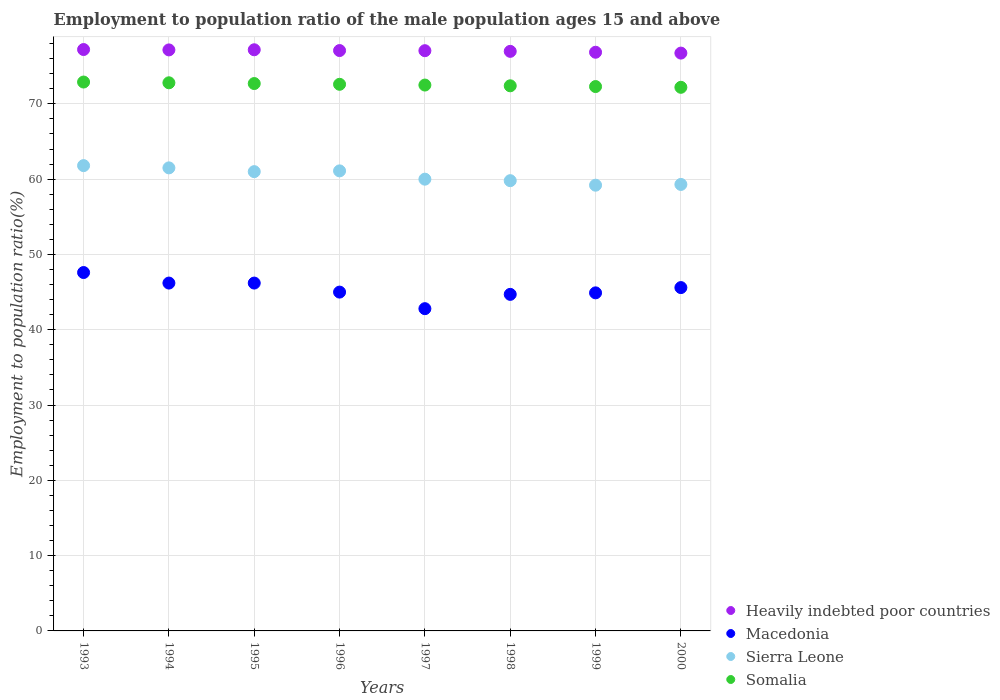What is the employment to population ratio in Macedonia in 1997?
Provide a short and direct response. 42.8. Across all years, what is the maximum employment to population ratio in Heavily indebted poor countries?
Provide a succinct answer. 77.22. Across all years, what is the minimum employment to population ratio in Somalia?
Make the answer very short. 72.2. In which year was the employment to population ratio in Somalia maximum?
Offer a very short reply. 1993. What is the total employment to population ratio in Macedonia in the graph?
Give a very brief answer. 363. What is the difference between the employment to population ratio in Sierra Leone in 1995 and that in 1996?
Your answer should be compact. -0.1. What is the difference between the employment to population ratio in Somalia in 1994 and the employment to population ratio in Heavily indebted poor countries in 1997?
Offer a very short reply. -4.26. What is the average employment to population ratio in Somalia per year?
Provide a short and direct response. 72.55. In the year 1993, what is the difference between the employment to population ratio in Macedonia and employment to population ratio in Heavily indebted poor countries?
Ensure brevity in your answer.  -29.62. What is the ratio of the employment to population ratio in Heavily indebted poor countries in 1996 to that in 1997?
Give a very brief answer. 1. Is the employment to population ratio in Macedonia in 1994 less than that in 1998?
Offer a very short reply. No. What is the difference between the highest and the second highest employment to population ratio in Sierra Leone?
Make the answer very short. 0.3. What is the difference between the highest and the lowest employment to population ratio in Macedonia?
Your answer should be compact. 4.8. Is the sum of the employment to population ratio in Sierra Leone in 1994 and 1995 greater than the maximum employment to population ratio in Heavily indebted poor countries across all years?
Keep it short and to the point. Yes. Is it the case that in every year, the sum of the employment to population ratio in Macedonia and employment to population ratio in Somalia  is greater than the employment to population ratio in Sierra Leone?
Offer a very short reply. Yes. How many dotlines are there?
Provide a short and direct response. 4. Where does the legend appear in the graph?
Give a very brief answer. Bottom right. What is the title of the graph?
Make the answer very short. Employment to population ratio of the male population ages 15 and above. Does "East Asia (all income levels)" appear as one of the legend labels in the graph?
Your answer should be very brief. No. What is the label or title of the Y-axis?
Offer a very short reply. Employment to population ratio(%). What is the Employment to population ratio(%) in Heavily indebted poor countries in 1993?
Your answer should be very brief. 77.22. What is the Employment to population ratio(%) of Macedonia in 1993?
Provide a short and direct response. 47.6. What is the Employment to population ratio(%) of Sierra Leone in 1993?
Offer a terse response. 61.8. What is the Employment to population ratio(%) of Somalia in 1993?
Provide a succinct answer. 72.9. What is the Employment to population ratio(%) in Heavily indebted poor countries in 1994?
Your answer should be compact. 77.17. What is the Employment to population ratio(%) in Macedonia in 1994?
Your answer should be very brief. 46.2. What is the Employment to population ratio(%) of Sierra Leone in 1994?
Your response must be concise. 61.5. What is the Employment to population ratio(%) in Somalia in 1994?
Your answer should be compact. 72.8. What is the Employment to population ratio(%) of Heavily indebted poor countries in 1995?
Give a very brief answer. 77.19. What is the Employment to population ratio(%) in Macedonia in 1995?
Your answer should be compact. 46.2. What is the Employment to population ratio(%) of Sierra Leone in 1995?
Provide a short and direct response. 61. What is the Employment to population ratio(%) of Somalia in 1995?
Provide a succinct answer. 72.7. What is the Employment to population ratio(%) of Heavily indebted poor countries in 1996?
Provide a short and direct response. 77.08. What is the Employment to population ratio(%) of Sierra Leone in 1996?
Your answer should be compact. 61.1. What is the Employment to population ratio(%) of Somalia in 1996?
Provide a short and direct response. 72.6. What is the Employment to population ratio(%) of Heavily indebted poor countries in 1997?
Offer a very short reply. 77.06. What is the Employment to population ratio(%) of Macedonia in 1997?
Make the answer very short. 42.8. What is the Employment to population ratio(%) in Sierra Leone in 1997?
Your answer should be very brief. 60. What is the Employment to population ratio(%) of Somalia in 1997?
Ensure brevity in your answer.  72.5. What is the Employment to population ratio(%) in Heavily indebted poor countries in 1998?
Offer a very short reply. 76.97. What is the Employment to population ratio(%) of Macedonia in 1998?
Keep it short and to the point. 44.7. What is the Employment to population ratio(%) in Sierra Leone in 1998?
Your answer should be compact. 59.8. What is the Employment to population ratio(%) of Somalia in 1998?
Your response must be concise. 72.4. What is the Employment to population ratio(%) in Heavily indebted poor countries in 1999?
Make the answer very short. 76.86. What is the Employment to population ratio(%) of Macedonia in 1999?
Provide a succinct answer. 44.9. What is the Employment to population ratio(%) of Sierra Leone in 1999?
Your answer should be very brief. 59.2. What is the Employment to population ratio(%) in Somalia in 1999?
Make the answer very short. 72.3. What is the Employment to population ratio(%) in Heavily indebted poor countries in 2000?
Give a very brief answer. 76.74. What is the Employment to population ratio(%) of Macedonia in 2000?
Offer a very short reply. 45.6. What is the Employment to population ratio(%) in Sierra Leone in 2000?
Make the answer very short. 59.3. What is the Employment to population ratio(%) of Somalia in 2000?
Offer a terse response. 72.2. Across all years, what is the maximum Employment to population ratio(%) in Heavily indebted poor countries?
Your response must be concise. 77.22. Across all years, what is the maximum Employment to population ratio(%) in Macedonia?
Offer a very short reply. 47.6. Across all years, what is the maximum Employment to population ratio(%) of Sierra Leone?
Provide a short and direct response. 61.8. Across all years, what is the maximum Employment to population ratio(%) of Somalia?
Offer a very short reply. 72.9. Across all years, what is the minimum Employment to population ratio(%) of Heavily indebted poor countries?
Offer a very short reply. 76.74. Across all years, what is the minimum Employment to population ratio(%) in Macedonia?
Your response must be concise. 42.8. Across all years, what is the minimum Employment to population ratio(%) of Sierra Leone?
Give a very brief answer. 59.2. Across all years, what is the minimum Employment to population ratio(%) of Somalia?
Your answer should be compact. 72.2. What is the total Employment to population ratio(%) in Heavily indebted poor countries in the graph?
Your answer should be very brief. 616.29. What is the total Employment to population ratio(%) in Macedonia in the graph?
Offer a terse response. 363. What is the total Employment to population ratio(%) in Sierra Leone in the graph?
Make the answer very short. 483.7. What is the total Employment to population ratio(%) of Somalia in the graph?
Make the answer very short. 580.4. What is the difference between the Employment to population ratio(%) in Heavily indebted poor countries in 1993 and that in 1994?
Give a very brief answer. 0.05. What is the difference between the Employment to population ratio(%) of Macedonia in 1993 and that in 1994?
Keep it short and to the point. 1.4. What is the difference between the Employment to population ratio(%) in Sierra Leone in 1993 and that in 1994?
Keep it short and to the point. 0.3. What is the difference between the Employment to population ratio(%) in Heavily indebted poor countries in 1993 and that in 1995?
Offer a very short reply. 0.03. What is the difference between the Employment to population ratio(%) in Macedonia in 1993 and that in 1995?
Provide a succinct answer. 1.4. What is the difference between the Employment to population ratio(%) of Sierra Leone in 1993 and that in 1995?
Offer a very short reply. 0.8. What is the difference between the Employment to population ratio(%) in Heavily indebted poor countries in 1993 and that in 1996?
Keep it short and to the point. 0.14. What is the difference between the Employment to population ratio(%) of Macedonia in 1993 and that in 1996?
Give a very brief answer. 2.6. What is the difference between the Employment to population ratio(%) in Sierra Leone in 1993 and that in 1996?
Ensure brevity in your answer.  0.7. What is the difference between the Employment to population ratio(%) of Somalia in 1993 and that in 1996?
Your response must be concise. 0.3. What is the difference between the Employment to population ratio(%) of Heavily indebted poor countries in 1993 and that in 1997?
Your answer should be compact. 0.15. What is the difference between the Employment to population ratio(%) in Sierra Leone in 1993 and that in 1997?
Provide a short and direct response. 1.8. What is the difference between the Employment to population ratio(%) of Somalia in 1993 and that in 1997?
Provide a succinct answer. 0.4. What is the difference between the Employment to population ratio(%) of Heavily indebted poor countries in 1993 and that in 1998?
Provide a short and direct response. 0.24. What is the difference between the Employment to population ratio(%) of Macedonia in 1993 and that in 1998?
Ensure brevity in your answer.  2.9. What is the difference between the Employment to population ratio(%) in Sierra Leone in 1993 and that in 1998?
Offer a terse response. 2. What is the difference between the Employment to population ratio(%) of Somalia in 1993 and that in 1998?
Offer a terse response. 0.5. What is the difference between the Employment to population ratio(%) in Heavily indebted poor countries in 1993 and that in 1999?
Your answer should be compact. 0.36. What is the difference between the Employment to population ratio(%) of Macedonia in 1993 and that in 1999?
Your answer should be compact. 2.7. What is the difference between the Employment to population ratio(%) in Somalia in 1993 and that in 1999?
Your answer should be compact. 0.6. What is the difference between the Employment to population ratio(%) of Heavily indebted poor countries in 1993 and that in 2000?
Ensure brevity in your answer.  0.47. What is the difference between the Employment to population ratio(%) of Macedonia in 1993 and that in 2000?
Keep it short and to the point. 2. What is the difference between the Employment to population ratio(%) of Sierra Leone in 1993 and that in 2000?
Make the answer very short. 2.5. What is the difference between the Employment to population ratio(%) in Somalia in 1993 and that in 2000?
Give a very brief answer. 0.7. What is the difference between the Employment to population ratio(%) of Heavily indebted poor countries in 1994 and that in 1995?
Make the answer very short. -0.02. What is the difference between the Employment to population ratio(%) of Sierra Leone in 1994 and that in 1995?
Keep it short and to the point. 0.5. What is the difference between the Employment to population ratio(%) in Somalia in 1994 and that in 1995?
Give a very brief answer. 0.1. What is the difference between the Employment to population ratio(%) in Heavily indebted poor countries in 1994 and that in 1996?
Your answer should be very brief. 0.09. What is the difference between the Employment to population ratio(%) of Macedonia in 1994 and that in 1996?
Offer a terse response. 1.2. What is the difference between the Employment to population ratio(%) of Heavily indebted poor countries in 1994 and that in 1997?
Your answer should be very brief. 0.1. What is the difference between the Employment to population ratio(%) of Macedonia in 1994 and that in 1997?
Ensure brevity in your answer.  3.4. What is the difference between the Employment to population ratio(%) in Sierra Leone in 1994 and that in 1997?
Your answer should be compact. 1.5. What is the difference between the Employment to population ratio(%) in Somalia in 1994 and that in 1997?
Offer a terse response. 0.3. What is the difference between the Employment to population ratio(%) in Heavily indebted poor countries in 1994 and that in 1998?
Keep it short and to the point. 0.19. What is the difference between the Employment to population ratio(%) in Macedonia in 1994 and that in 1998?
Your answer should be compact. 1.5. What is the difference between the Employment to population ratio(%) of Heavily indebted poor countries in 1994 and that in 1999?
Make the answer very short. 0.31. What is the difference between the Employment to population ratio(%) in Macedonia in 1994 and that in 1999?
Provide a short and direct response. 1.3. What is the difference between the Employment to population ratio(%) in Heavily indebted poor countries in 1994 and that in 2000?
Provide a short and direct response. 0.42. What is the difference between the Employment to population ratio(%) in Heavily indebted poor countries in 1995 and that in 1996?
Keep it short and to the point. 0.1. What is the difference between the Employment to population ratio(%) in Sierra Leone in 1995 and that in 1996?
Provide a short and direct response. -0.1. What is the difference between the Employment to population ratio(%) of Heavily indebted poor countries in 1995 and that in 1997?
Give a very brief answer. 0.12. What is the difference between the Employment to population ratio(%) of Sierra Leone in 1995 and that in 1997?
Offer a terse response. 1. What is the difference between the Employment to population ratio(%) of Heavily indebted poor countries in 1995 and that in 1998?
Give a very brief answer. 0.21. What is the difference between the Employment to population ratio(%) of Macedonia in 1995 and that in 1998?
Ensure brevity in your answer.  1.5. What is the difference between the Employment to population ratio(%) of Somalia in 1995 and that in 1998?
Ensure brevity in your answer.  0.3. What is the difference between the Employment to population ratio(%) in Heavily indebted poor countries in 1995 and that in 1999?
Keep it short and to the point. 0.33. What is the difference between the Employment to population ratio(%) of Sierra Leone in 1995 and that in 1999?
Your answer should be very brief. 1.8. What is the difference between the Employment to population ratio(%) of Somalia in 1995 and that in 1999?
Provide a short and direct response. 0.4. What is the difference between the Employment to population ratio(%) in Heavily indebted poor countries in 1995 and that in 2000?
Make the answer very short. 0.44. What is the difference between the Employment to population ratio(%) of Heavily indebted poor countries in 1996 and that in 1997?
Offer a terse response. 0.02. What is the difference between the Employment to population ratio(%) of Macedonia in 1996 and that in 1997?
Your answer should be compact. 2.2. What is the difference between the Employment to population ratio(%) in Sierra Leone in 1996 and that in 1997?
Ensure brevity in your answer.  1.1. What is the difference between the Employment to population ratio(%) of Somalia in 1996 and that in 1997?
Provide a succinct answer. 0.1. What is the difference between the Employment to population ratio(%) in Heavily indebted poor countries in 1996 and that in 1998?
Your response must be concise. 0.11. What is the difference between the Employment to population ratio(%) in Somalia in 1996 and that in 1998?
Offer a very short reply. 0.2. What is the difference between the Employment to population ratio(%) in Heavily indebted poor countries in 1996 and that in 1999?
Provide a succinct answer. 0.23. What is the difference between the Employment to population ratio(%) in Macedonia in 1996 and that in 1999?
Offer a very short reply. 0.1. What is the difference between the Employment to population ratio(%) in Somalia in 1996 and that in 1999?
Provide a short and direct response. 0.3. What is the difference between the Employment to population ratio(%) of Heavily indebted poor countries in 1996 and that in 2000?
Give a very brief answer. 0.34. What is the difference between the Employment to population ratio(%) of Macedonia in 1996 and that in 2000?
Keep it short and to the point. -0.6. What is the difference between the Employment to population ratio(%) in Heavily indebted poor countries in 1997 and that in 1998?
Your answer should be very brief. 0.09. What is the difference between the Employment to population ratio(%) in Heavily indebted poor countries in 1997 and that in 1999?
Provide a succinct answer. 0.21. What is the difference between the Employment to population ratio(%) of Macedonia in 1997 and that in 1999?
Your answer should be very brief. -2.1. What is the difference between the Employment to population ratio(%) of Sierra Leone in 1997 and that in 1999?
Ensure brevity in your answer.  0.8. What is the difference between the Employment to population ratio(%) of Heavily indebted poor countries in 1997 and that in 2000?
Your response must be concise. 0.32. What is the difference between the Employment to population ratio(%) of Macedonia in 1997 and that in 2000?
Your response must be concise. -2.8. What is the difference between the Employment to population ratio(%) in Sierra Leone in 1997 and that in 2000?
Your response must be concise. 0.7. What is the difference between the Employment to population ratio(%) in Heavily indebted poor countries in 1998 and that in 1999?
Make the answer very short. 0.12. What is the difference between the Employment to population ratio(%) in Sierra Leone in 1998 and that in 1999?
Provide a succinct answer. 0.6. What is the difference between the Employment to population ratio(%) of Heavily indebted poor countries in 1998 and that in 2000?
Provide a short and direct response. 0.23. What is the difference between the Employment to population ratio(%) in Macedonia in 1998 and that in 2000?
Keep it short and to the point. -0.9. What is the difference between the Employment to population ratio(%) in Sierra Leone in 1998 and that in 2000?
Offer a terse response. 0.5. What is the difference between the Employment to population ratio(%) of Heavily indebted poor countries in 1999 and that in 2000?
Your response must be concise. 0.11. What is the difference between the Employment to population ratio(%) of Heavily indebted poor countries in 1993 and the Employment to population ratio(%) of Macedonia in 1994?
Offer a very short reply. 31.02. What is the difference between the Employment to population ratio(%) in Heavily indebted poor countries in 1993 and the Employment to population ratio(%) in Sierra Leone in 1994?
Ensure brevity in your answer.  15.72. What is the difference between the Employment to population ratio(%) in Heavily indebted poor countries in 1993 and the Employment to population ratio(%) in Somalia in 1994?
Make the answer very short. 4.42. What is the difference between the Employment to population ratio(%) of Macedonia in 1993 and the Employment to population ratio(%) of Somalia in 1994?
Your answer should be compact. -25.2. What is the difference between the Employment to population ratio(%) in Sierra Leone in 1993 and the Employment to population ratio(%) in Somalia in 1994?
Offer a terse response. -11. What is the difference between the Employment to population ratio(%) of Heavily indebted poor countries in 1993 and the Employment to population ratio(%) of Macedonia in 1995?
Your answer should be compact. 31.02. What is the difference between the Employment to population ratio(%) of Heavily indebted poor countries in 1993 and the Employment to population ratio(%) of Sierra Leone in 1995?
Offer a very short reply. 16.22. What is the difference between the Employment to population ratio(%) in Heavily indebted poor countries in 1993 and the Employment to population ratio(%) in Somalia in 1995?
Offer a terse response. 4.52. What is the difference between the Employment to population ratio(%) of Macedonia in 1993 and the Employment to population ratio(%) of Somalia in 1995?
Give a very brief answer. -25.1. What is the difference between the Employment to population ratio(%) in Sierra Leone in 1993 and the Employment to population ratio(%) in Somalia in 1995?
Offer a terse response. -10.9. What is the difference between the Employment to population ratio(%) in Heavily indebted poor countries in 1993 and the Employment to population ratio(%) in Macedonia in 1996?
Offer a terse response. 32.22. What is the difference between the Employment to population ratio(%) of Heavily indebted poor countries in 1993 and the Employment to population ratio(%) of Sierra Leone in 1996?
Provide a short and direct response. 16.12. What is the difference between the Employment to population ratio(%) in Heavily indebted poor countries in 1993 and the Employment to population ratio(%) in Somalia in 1996?
Offer a terse response. 4.62. What is the difference between the Employment to population ratio(%) in Macedonia in 1993 and the Employment to population ratio(%) in Sierra Leone in 1996?
Offer a terse response. -13.5. What is the difference between the Employment to population ratio(%) of Macedonia in 1993 and the Employment to population ratio(%) of Somalia in 1996?
Your answer should be compact. -25. What is the difference between the Employment to population ratio(%) in Sierra Leone in 1993 and the Employment to population ratio(%) in Somalia in 1996?
Your answer should be very brief. -10.8. What is the difference between the Employment to population ratio(%) of Heavily indebted poor countries in 1993 and the Employment to population ratio(%) of Macedonia in 1997?
Give a very brief answer. 34.42. What is the difference between the Employment to population ratio(%) in Heavily indebted poor countries in 1993 and the Employment to population ratio(%) in Sierra Leone in 1997?
Your answer should be compact. 17.22. What is the difference between the Employment to population ratio(%) in Heavily indebted poor countries in 1993 and the Employment to population ratio(%) in Somalia in 1997?
Your response must be concise. 4.72. What is the difference between the Employment to population ratio(%) in Macedonia in 1993 and the Employment to population ratio(%) in Somalia in 1997?
Offer a terse response. -24.9. What is the difference between the Employment to population ratio(%) of Sierra Leone in 1993 and the Employment to population ratio(%) of Somalia in 1997?
Offer a very short reply. -10.7. What is the difference between the Employment to population ratio(%) in Heavily indebted poor countries in 1993 and the Employment to population ratio(%) in Macedonia in 1998?
Your response must be concise. 32.52. What is the difference between the Employment to population ratio(%) in Heavily indebted poor countries in 1993 and the Employment to population ratio(%) in Sierra Leone in 1998?
Your response must be concise. 17.42. What is the difference between the Employment to population ratio(%) of Heavily indebted poor countries in 1993 and the Employment to population ratio(%) of Somalia in 1998?
Give a very brief answer. 4.82. What is the difference between the Employment to population ratio(%) of Macedonia in 1993 and the Employment to population ratio(%) of Somalia in 1998?
Make the answer very short. -24.8. What is the difference between the Employment to population ratio(%) in Heavily indebted poor countries in 1993 and the Employment to population ratio(%) in Macedonia in 1999?
Your response must be concise. 32.32. What is the difference between the Employment to population ratio(%) of Heavily indebted poor countries in 1993 and the Employment to population ratio(%) of Sierra Leone in 1999?
Make the answer very short. 18.02. What is the difference between the Employment to population ratio(%) of Heavily indebted poor countries in 1993 and the Employment to population ratio(%) of Somalia in 1999?
Keep it short and to the point. 4.92. What is the difference between the Employment to population ratio(%) in Macedonia in 1993 and the Employment to population ratio(%) in Somalia in 1999?
Your response must be concise. -24.7. What is the difference between the Employment to population ratio(%) of Sierra Leone in 1993 and the Employment to population ratio(%) of Somalia in 1999?
Keep it short and to the point. -10.5. What is the difference between the Employment to population ratio(%) of Heavily indebted poor countries in 1993 and the Employment to population ratio(%) of Macedonia in 2000?
Ensure brevity in your answer.  31.62. What is the difference between the Employment to population ratio(%) of Heavily indebted poor countries in 1993 and the Employment to population ratio(%) of Sierra Leone in 2000?
Ensure brevity in your answer.  17.92. What is the difference between the Employment to population ratio(%) of Heavily indebted poor countries in 1993 and the Employment to population ratio(%) of Somalia in 2000?
Provide a short and direct response. 5.02. What is the difference between the Employment to population ratio(%) in Macedonia in 1993 and the Employment to population ratio(%) in Somalia in 2000?
Your answer should be compact. -24.6. What is the difference between the Employment to population ratio(%) in Heavily indebted poor countries in 1994 and the Employment to population ratio(%) in Macedonia in 1995?
Provide a short and direct response. 30.97. What is the difference between the Employment to population ratio(%) of Heavily indebted poor countries in 1994 and the Employment to population ratio(%) of Sierra Leone in 1995?
Your answer should be very brief. 16.17. What is the difference between the Employment to population ratio(%) in Heavily indebted poor countries in 1994 and the Employment to population ratio(%) in Somalia in 1995?
Keep it short and to the point. 4.47. What is the difference between the Employment to population ratio(%) of Macedonia in 1994 and the Employment to population ratio(%) of Sierra Leone in 1995?
Your response must be concise. -14.8. What is the difference between the Employment to population ratio(%) in Macedonia in 1994 and the Employment to population ratio(%) in Somalia in 1995?
Offer a terse response. -26.5. What is the difference between the Employment to population ratio(%) in Heavily indebted poor countries in 1994 and the Employment to population ratio(%) in Macedonia in 1996?
Provide a short and direct response. 32.17. What is the difference between the Employment to population ratio(%) in Heavily indebted poor countries in 1994 and the Employment to population ratio(%) in Sierra Leone in 1996?
Your answer should be compact. 16.07. What is the difference between the Employment to population ratio(%) of Heavily indebted poor countries in 1994 and the Employment to population ratio(%) of Somalia in 1996?
Provide a succinct answer. 4.57. What is the difference between the Employment to population ratio(%) of Macedonia in 1994 and the Employment to population ratio(%) of Sierra Leone in 1996?
Keep it short and to the point. -14.9. What is the difference between the Employment to population ratio(%) of Macedonia in 1994 and the Employment to population ratio(%) of Somalia in 1996?
Offer a terse response. -26.4. What is the difference between the Employment to population ratio(%) in Heavily indebted poor countries in 1994 and the Employment to population ratio(%) in Macedonia in 1997?
Provide a short and direct response. 34.37. What is the difference between the Employment to population ratio(%) of Heavily indebted poor countries in 1994 and the Employment to population ratio(%) of Sierra Leone in 1997?
Your response must be concise. 17.17. What is the difference between the Employment to population ratio(%) of Heavily indebted poor countries in 1994 and the Employment to population ratio(%) of Somalia in 1997?
Offer a terse response. 4.67. What is the difference between the Employment to population ratio(%) of Macedonia in 1994 and the Employment to population ratio(%) of Somalia in 1997?
Your answer should be very brief. -26.3. What is the difference between the Employment to population ratio(%) in Sierra Leone in 1994 and the Employment to population ratio(%) in Somalia in 1997?
Provide a short and direct response. -11. What is the difference between the Employment to population ratio(%) in Heavily indebted poor countries in 1994 and the Employment to population ratio(%) in Macedonia in 1998?
Your answer should be compact. 32.47. What is the difference between the Employment to population ratio(%) in Heavily indebted poor countries in 1994 and the Employment to population ratio(%) in Sierra Leone in 1998?
Provide a short and direct response. 17.37. What is the difference between the Employment to population ratio(%) in Heavily indebted poor countries in 1994 and the Employment to population ratio(%) in Somalia in 1998?
Keep it short and to the point. 4.77. What is the difference between the Employment to population ratio(%) of Macedonia in 1994 and the Employment to population ratio(%) of Sierra Leone in 1998?
Provide a succinct answer. -13.6. What is the difference between the Employment to population ratio(%) in Macedonia in 1994 and the Employment to population ratio(%) in Somalia in 1998?
Make the answer very short. -26.2. What is the difference between the Employment to population ratio(%) of Sierra Leone in 1994 and the Employment to population ratio(%) of Somalia in 1998?
Ensure brevity in your answer.  -10.9. What is the difference between the Employment to population ratio(%) in Heavily indebted poor countries in 1994 and the Employment to population ratio(%) in Macedonia in 1999?
Ensure brevity in your answer.  32.27. What is the difference between the Employment to population ratio(%) of Heavily indebted poor countries in 1994 and the Employment to population ratio(%) of Sierra Leone in 1999?
Ensure brevity in your answer.  17.97. What is the difference between the Employment to population ratio(%) of Heavily indebted poor countries in 1994 and the Employment to population ratio(%) of Somalia in 1999?
Ensure brevity in your answer.  4.87. What is the difference between the Employment to population ratio(%) of Macedonia in 1994 and the Employment to population ratio(%) of Sierra Leone in 1999?
Provide a succinct answer. -13. What is the difference between the Employment to population ratio(%) of Macedonia in 1994 and the Employment to population ratio(%) of Somalia in 1999?
Make the answer very short. -26.1. What is the difference between the Employment to population ratio(%) in Sierra Leone in 1994 and the Employment to population ratio(%) in Somalia in 1999?
Keep it short and to the point. -10.8. What is the difference between the Employment to population ratio(%) of Heavily indebted poor countries in 1994 and the Employment to population ratio(%) of Macedonia in 2000?
Offer a very short reply. 31.57. What is the difference between the Employment to population ratio(%) in Heavily indebted poor countries in 1994 and the Employment to population ratio(%) in Sierra Leone in 2000?
Make the answer very short. 17.87. What is the difference between the Employment to population ratio(%) in Heavily indebted poor countries in 1994 and the Employment to population ratio(%) in Somalia in 2000?
Offer a very short reply. 4.97. What is the difference between the Employment to population ratio(%) in Macedonia in 1994 and the Employment to population ratio(%) in Sierra Leone in 2000?
Keep it short and to the point. -13.1. What is the difference between the Employment to population ratio(%) of Sierra Leone in 1994 and the Employment to population ratio(%) of Somalia in 2000?
Provide a succinct answer. -10.7. What is the difference between the Employment to population ratio(%) in Heavily indebted poor countries in 1995 and the Employment to population ratio(%) in Macedonia in 1996?
Your response must be concise. 32.19. What is the difference between the Employment to population ratio(%) of Heavily indebted poor countries in 1995 and the Employment to population ratio(%) of Sierra Leone in 1996?
Offer a very short reply. 16.09. What is the difference between the Employment to population ratio(%) of Heavily indebted poor countries in 1995 and the Employment to population ratio(%) of Somalia in 1996?
Offer a very short reply. 4.59. What is the difference between the Employment to population ratio(%) in Macedonia in 1995 and the Employment to population ratio(%) in Sierra Leone in 1996?
Your answer should be compact. -14.9. What is the difference between the Employment to population ratio(%) of Macedonia in 1995 and the Employment to population ratio(%) of Somalia in 1996?
Give a very brief answer. -26.4. What is the difference between the Employment to population ratio(%) in Heavily indebted poor countries in 1995 and the Employment to population ratio(%) in Macedonia in 1997?
Provide a succinct answer. 34.39. What is the difference between the Employment to population ratio(%) in Heavily indebted poor countries in 1995 and the Employment to population ratio(%) in Sierra Leone in 1997?
Provide a short and direct response. 17.19. What is the difference between the Employment to population ratio(%) in Heavily indebted poor countries in 1995 and the Employment to population ratio(%) in Somalia in 1997?
Offer a very short reply. 4.69. What is the difference between the Employment to population ratio(%) in Macedonia in 1995 and the Employment to population ratio(%) in Sierra Leone in 1997?
Your response must be concise. -13.8. What is the difference between the Employment to population ratio(%) in Macedonia in 1995 and the Employment to population ratio(%) in Somalia in 1997?
Keep it short and to the point. -26.3. What is the difference between the Employment to population ratio(%) of Sierra Leone in 1995 and the Employment to population ratio(%) of Somalia in 1997?
Your answer should be compact. -11.5. What is the difference between the Employment to population ratio(%) in Heavily indebted poor countries in 1995 and the Employment to population ratio(%) in Macedonia in 1998?
Offer a very short reply. 32.49. What is the difference between the Employment to population ratio(%) of Heavily indebted poor countries in 1995 and the Employment to population ratio(%) of Sierra Leone in 1998?
Provide a succinct answer. 17.39. What is the difference between the Employment to population ratio(%) of Heavily indebted poor countries in 1995 and the Employment to population ratio(%) of Somalia in 1998?
Your response must be concise. 4.79. What is the difference between the Employment to population ratio(%) of Macedonia in 1995 and the Employment to population ratio(%) of Somalia in 1998?
Offer a terse response. -26.2. What is the difference between the Employment to population ratio(%) in Heavily indebted poor countries in 1995 and the Employment to population ratio(%) in Macedonia in 1999?
Provide a succinct answer. 32.29. What is the difference between the Employment to population ratio(%) of Heavily indebted poor countries in 1995 and the Employment to population ratio(%) of Sierra Leone in 1999?
Provide a short and direct response. 17.99. What is the difference between the Employment to population ratio(%) in Heavily indebted poor countries in 1995 and the Employment to population ratio(%) in Somalia in 1999?
Give a very brief answer. 4.89. What is the difference between the Employment to population ratio(%) in Macedonia in 1995 and the Employment to population ratio(%) in Somalia in 1999?
Your response must be concise. -26.1. What is the difference between the Employment to population ratio(%) of Heavily indebted poor countries in 1995 and the Employment to population ratio(%) of Macedonia in 2000?
Your answer should be compact. 31.59. What is the difference between the Employment to population ratio(%) of Heavily indebted poor countries in 1995 and the Employment to population ratio(%) of Sierra Leone in 2000?
Keep it short and to the point. 17.89. What is the difference between the Employment to population ratio(%) of Heavily indebted poor countries in 1995 and the Employment to population ratio(%) of Somalia in 2000?
Your answer should be compact. 4.99. What is the difference between the Employment to population ratio(%) of Macedonia in 1995 and the Employment to population ratio(%) of Somalia in 2000?
Your answer should be compact. -26. What is the difference between the Employment to population ratio(%) of Sierra Leone in 1995 and the Employment to population ratio(%) of Somalia in 2000?
Offer a very short reply. -11.2. What is the difference between the Employment to population ratio(%) in Heavily indebted poor countries in 1996 and the Employment to population ratio(%) in Macedonia in 1997?
Offer a very short reply. 34.28. What is the difference between the Employment to population ratio(%) in Heavily indebted poor countries in 1996 and the Employment to population ratio(%) in Sierra Leone in 1997?
Provide a short and direct response. 17.08. What is the difference between the Employment to population ratio(%) of Heavily indebted poor countries in 1996 and the Employment to population ratio(%) of Somalia in 1997?
Keep it short and to the point. 4.58. What is the difference between the Employment to population ratio(%) of Macedonia in 1996 and the Employment to population ratio(%) of Sierra Leone in 1997?
Provide a succinct answer. -15. What is the difference between the Employment to population ratio(%) in Macedonia in 1996 and the Employment to population ratio(%) in Somalia in 1997?
Ensure brevity in your answer.  -27.5. What is the difference between the Employment to population ratio(%) in Sierra Leone in 1996 and the Employment to population ratio(%) in Somalia in 1997?
Your response must be concise. -11.4. What is the difference between the Employment to population ratio(%) in Heavily indebted poor countries in 1996 and the Employment to population ratio(%) in Macedonia in 1998?
Offer a terse response. 32.38. What is the difference between the Employment to population ratio(%) of Heavily indebted poor countries in 1996 and the Employment to population ratio(%) of Sierra Leone in 1998?
Provide a short and direct response. 17.28. What is the difference between the Employment to population ratio(%) of Heavily indebted poor countries in 1996 and the Employment to population ratio(%) of Somalia in 1998?
Make the answer very short. 4.68. What is the difference between the Employment to population ratio(%) in Macedonia in 1996 and the Employment to population ratio(%) in Sierra Leone in 1998?
Provide a short and direct response. -14.8. What is the difference between the Employment to population ratio(%) in Macedonia in 1996 and the Employment to population ratio(%) in Somalia in 1998?
Provide a succinct answer. -27.4. What is the difference between the Employment to population ratio(%) of Sierra Leone in 1996 and the Employment to population ratio(%) of Somalia in 1998?
Make the answer very short. -11.3. What is the difference between the Employment to population ratio(%) in Heavily indebted poor countries in 1996 and the Employment to population ratio(%) in Macedonia in 1999?
Offer a very short reply. 32.18. What is the difference between the Employment to population ratio(%) of Heavily indebted poor countries in 1996 and the Employment to population ratio(%) of Sierra Leone in 1999?
Your answer should be compact. 17.88. What is the difference between the Employment to population ratio(%) of Heavily indebted poor countries in 1996 and the Employment to population ratio(%) of Somalia in 1999?
Offer a very short reply. 4.78. What is the difference between the Employment to population ratio(%) of Macedonia in 1996 and the Employment to population ratio(%) of Sierra Leone in 1999?
Make the answer very short. -14.2. What is the difference between the Employment to population ratio(%) in Macedonia in 1996 and the Employment to population ratio(%) in Somalia in 1999?
Make the answer very short. -27.3. What is the difference between the Employment to population ratio(%) of Sierra Leone in 1996 and the Employment to population ratio(%) of Somalia in 1999?
Your answer should be very brief. -11.2. What is the difference between the Employment to population ratio(%) of Heavily indebted poor countries in 1996 and the Employment to population ratio(%) of Macedonia in 2000?
Make the answer very short. 31.48. What is the difference between the Employment to population ratio(%) in Heavily indebted poor countries in 1996 and the Employment to population ratio(%) in Sierra Leone in 2000?
Offer a terse response. 17.78. What is the difference between the Employment to population ratio(%) in Heavily indebted poor countries in 1996 and the Employment to population ratio(%) in Somalia in 2000?
Give a very brief answer. 4.88. What is the difference between the Employment to population ratio(%) in Macedonia in 1996 and the Employment to population ratio(%) in Sierra Leone in 2000?
Provide a short and direct response. -14.3. What is the difference between the Employment to population ratio(%) in Macedonia in 1996 and the Employment to population ratio(%) in Somalia in 2000?
Ensure brevity in your answer.  -27.2. What is the difference between the Employment to population ratio(%) in Heavily indebted poor countries in 1997 and the Employment to population ratio(%) in Macedonia in 1998?
Provide a succinct answer. 32.36. What is the difference between the Employment to population ratio(%) in Heavily indebted poor countries in 1997 and the Employment to population ratio(%) in Sierra Leone in 1998?
Offer a terse response. 17.26. What is the difference between the Employment to population ratio(%) in Heavily indebted poor countries in 1997 and the Employment to population ratio(%) in Somalia in 1998?
Give a very brief answer. 4.66. What is the difference between the Employment to population ratio(%) of Macedonia in 1997 and the Employment to population ratio(%) of Sierra Leone in 1998?
Keep it short and to the point. -17. What is the difference between the Employment to population ratio(%) in Macedonia in 1997 and the Employment to population ratio(%) in Somalia in 1998?
Your answer should be compact. -29.6. What is the difference between the Employment to population ratio(%) in Sierra Leone in 1997 and the Employment to population ratio(%) in Somalia in 1998?
Ensure brevity in your answer.  -12.4. What is the difference between the Employment to population ratio(%) in Heavily indebted poor countries in 1997 and the Employment to population ratio(%) in Macedonia in 1999?
Provide a succinct answer. 32.16. What is the difference between the Employment to population ratio(%) of Heavily indebted poor countries in 1997 and the Employment to population ratio(%) of Sierra Leone in 1999?
Offer a very short reply. 17.86. What is the difference between the Employment to population ratio(%) of Heavily indebted poor countries in 1997 and the Employment to population ratio(%) of Somalia in 1999?
Provide a succinct answer. 4.76. What is the difference between the Employment to population ratio(%) of Macedonia in 1997 and the Employment to population ratio(%) of Sierra Leone in 1999?
Make the answer very short. -16.4. What is the difference between the Employment to population ratio(%) in Macedonia in 1997 and the Employment to population ratio(%) in Somalia in 1999?
Provide a succinct answer. -29.5. What is the difference between the Employment to population ratio(%) in Sierra Leone in 1997 and the Employment to population ratio(%) in Somalia in 1999?
Offer a very short reply. -12.3. What is the difference between the Employment to population ratio(%) of Heavily indebted poor countries in 1997 and the Employment to population ratio(%) of Macedonia in 2000?
Ensure brevity in your answer.  31.46. What is the difference between the Employment to population ratio(%) of Heavily indebted poor countries in 1997 and the Employment to population ratio(%) of Sierra Leone in 2000?
Make the answer very short. 17.76. What is the difference between the Employment to population ratio(%) of Heavily indebted poor countries in 1997 and the Employment to population ratio(%) of Somalia in 2000?
Offer a very short reply. 4.86. What is the difference between the Employment to population ratio(%) of Macedonia in 1997 and the Employment to population ratio(%) of Sierra Leone in 2000?
Ensure brevity in your answer.  -16.5. What is the difference between the Employment to population ratio(%) of Macedonia in 1997 and the Employment to population ratio(%) of Somalia in 2000?
Ensure brevity in your answer.  -29.4. What is the difference between the Employment to population ratio(%) in Sierra Leone in 1997 and the Employment to population ratio(%) in Somalia in 2000?
Your response must be concise. -12.2. What is the difference between the Employment to population ratio(%) of Heavily indebted poor countries in 1998 and the Employment to population ratio(%) of Macedonia in 1999?
Give a very brief answer. 32.07. What is the difference between the Employment to population ratio(%) in Heavily indebted poor countries in 1998 and the Employment to population ratio(%) in Sierra Leone in 1999?
Offer a very short reply. 17.77. What is the difference between the Employment to population ratio(%) of Heavily indebted poor countries in 1998 and the Employment to population ratio(%) of Somalia in 1999?
Ensure brevity in your answer.  4.67. What is the difference between the Employment to population ratio(%) of Macedonia in 1998 and the Employment to population ratio(%) of Somalia in 1999?
Offer a terse response. -27.6. What is the difference between the Employment to population ratio(%) of Sierra Leone in 1998 and the Employment to population ratio(%) of Somalia in 1999?
Your response must be concise. -12.5. What is the difference between the Employment to population ratio(%) of Heavily indebted poor countries in 1998 and the Employment to population ratio(%) of Macedonia in 2000?
Provide a succinct answer. 31.37. What is the difference between the Employment to population ratio(%) in Heavily indebted poor countries in 1998 and the Employment to population ratio(%) in Sierra Leone in 2000?
Provide a short and direct response. 17.67. What is the difference between the Employment to population ratio(%) of Heavily indebted poor countries in 1998 and the Employment to population ratio(%) of Somalia in 2000?
Your answer should be very brief. 4.77. What is the difference between the Employment to population ratio(%) in Macedonia in 1998 and the Employment to population ratio(%) in Sierra Leone in 2000?
Keep it short and to the point. -14.6. What is the difference between the Employment to population ratio(%) in Macedonia in 1998 and the Employment to population ratio(%) in Somalia in 2000?
Provide a short and direct response. -27.5. What is the difference between the Employment to population ratio(%) of Heavily indebted poor countries in 1999 and the Employment to population ratio(%) of Macedonia in 2000?
Provide a short and direct response. 31.26. What is the difference between the Employment to population ratio(%) of Heavily indebted poor countries in 1999 and the Employment to population ratio(%) of Sierra Leone in 2000?
Your answer should be compact. 17.56. What is the difference between the Employment to population ratio(%) in Heavily indebted poor countries in 1999 and the Employment to population ratio(%) in Somalia in 2000?
Your answer should be compact. 4.66. What is the difference between the Employment to population ratio(%) of Macedonia in 1999 and the Employment to population ratio(%) of Sierra Leone in 2000?
Give a very brief answer. -14.4. What is the difference between the Employment to population ratio(%) in Macedonia in 1999 and the Employment to population ratio(%) in Somalia in 2000?
Offer a very short reply. -27.3. What is the difference between the Employment to population ratio(%) in Sierra Leone in 1999 and the Employment to population ratio(%) in Somalia in 2000?
Ensure brevity in your answer.  -13. What is the average Employment to population ratio(%) in Heavily indebted poor countries per year?
Make the answer very short. 77.04. What is the average Employment to population ratio(%) in Macedonia per year?
Provide a short and direct response. 45.38. What is the average Employment to population ratio(%) of Sierra Leone per year?
Your response must be concise. 60.46. What is the average Employment to population ratio(%) in Somalia per year?
Ensure brevity in your answer.  72.55. In the year 1993, what is the difference between the Employment to population ratio(%) in Heavily indebted poor countries and Employment to population ratio(%) in Macedonia?
Make the answer very short. 29.62. In the year 1993, what is the difference between the Employment to population ratio(%) in Heavily indebted poor countries and Employment to population ratio(%) in Sierra Leone?
Your answer should be very brief. 15.42. In the year 1993, what is the difference between the Employment to population ratio(%) in Heavily indebted poor countries and Employment to population ratio(%) in Somalia?
Provide a succinct answer. 4.32. In the year 1993, what is the difference between the Employment to population ratio(%) in Macedonia and Employment to population ratio(%) in Sierra Leone?
Your response must be concise. -14.2. In the year 1993, what is the difference between the Employment to population ratio(%) in Macedonia and Employment to population ratio(%) in Somalia?
Your response must be concise. -25.3. In the year 1993, what is the difference between the Employment to population ratio(%) in Sierra Leone and Employment to population ratio(%) in Somalia?
Provide a succinct answer. -11.1. In the year 1994, what is the difference between the Employment to population ratio(%) of Heavily indebted poor countries and Employment to population ratio(%) of Macedonia?
Ensure brevity in your answer.  30.97. In the year 1994, what is the difference between the Employment to population ratio(%) of Heavily indebted poor countries and Employment to population ratio(%) of Sierra Leone?
Your response must be concise. 15.67. In the year 1994, what is the difference between the Employment to population ratio(%) of Heavily indebted poor countries and Employment to population ratio(%) of Somalia?
Keep it short and to the point. 4.37. In the year 1994, what is the difference between the Employment to population ratio(%) in Macedonia and Employment to population ratio(%) in Sierra Leone?
Offer a very short reply. -15.3. In the year 1994, what is the difference between the Employment to population ratio(%) in Macedonia and Employment to population ratio(%) in Somalia?
Your answer should be compact. -26.6. In the year 1994, what is the difference between the Employment to population ratio(%) of Sierra Leone and Employment to population ratio(%) of Somalia?
Make the answer very short. -11.3. In the year 1995, what is the difference between the Employment to population ratio(%) of Heavily indebted poor countries and Employment to population ratio(%) of Macedonia?
Ensure brevity in your answer.  30.99. In the year 1995, what is the difference between the Employment to population ratio(%) of Heavily indebted poor countries and Employment to population ratio(%) of Sierra Leone?
Make the answer very short. 16.19. In the year 1995, what is the difference between the Employment to population ratio(%) in Heavily indebted poor countries and Employment to population ratio(%) in Somalia?
Make the answer very short. 4.49. In the year 1995, what is the difference between the Employment to population ratio(%) in Macedonia and Employment to population ratio(%) in Sierra Leone?
Ensure brevity in your answer.  -14.8. In the year 1995, what is the difference between the Employment to population ratio(%) in Macedonia and Employment to population ratio(%) in Somalia?
Ensure brevity in your answer.  -26.5. In the year 1996, what is the difference between the Employment to population ratio(%) of Heavily indebted poor countries and Employment to population ratio(%) of Macedonia?
Ensure brevity in your answer.  32.08. In the year 1996, what is the difference between the Employment to population ratio(%) of Heavily indebted poor countries and Employment to population ratio(%) of Sierra Leone?
Make the answer very short. 15.98. In the year 1996, what is the difference between the Employment to population ratio(%) of Heavily indebted poor countries and Employment to population ratio(%) of Somalia?
Your answer should be compact. 4.48. In the year 1996, what is the difference between the Employment to population ratio(%) in Macedonia and Employment to population ratio(%) in Sierra Leone?
Provide a succinct answer. -16.1. In the year 1996, what is the difference between the Employment to population ratio(%) in Macedonia and Employment to population ratio(%) in Somalia?
Provide a short and direct response. -27.6. In the year 1997, what is the difference between the Employment to population ratio(%) of Heavily indebted poor countries and Employment to population ratio(%) of Macedonia?
Offer a terse response. 34.26. In the year 1997, what is the difference between the Employment to population ratio(%) of Heavily indebted poor countries and Employment to population ratio(%) of Sierra Leone?
Offer a very short reply. 17.06. In the year 1997, what is the difference between the Employment to population ratio(%) of Heavily indebted poor countries and Employment to population ratio(%) of Somalia?
Offer a very short reply. 4.56. In the year 1997, what is the difference between the Employment to population ratio(%) of Macedonia and Employment to population ratio(%) of Sierra Leone?
Your answer should be compact. -17.2. In the year 1997, what is the difference between the Employment to population ratio(%) in Macedonia and Employment to population ratio(%) in Somalia?
Your response must be concise. -29.7. In the year 1998, what is the difference between the Employment to population ratio(%) in Heavily indebted poor countries and Employment to population ratio(%) in Macedonia?
Your response must be concise. 32.27. In the year 1998, what is the difference between the Employment to population ratio(%) of Heavily indebted poor countries and Employment to population ratio(%) of Sierra Leone?
Ensure brevity in your answer.  17.17. In the year 1998, what is the difference between the Employment to population ratio(%) of Heavily indebted poor countries and Employment to population ratio(%) of Somalia?
Provide a short and direct response. 4.57. In the year 1998, what is the difference between the Employment to population ratio(%) in Macedonia and Employment to population ratio(%) in Sierra Leone?
Make the answer very short. -15.1. In the year 1998, what is the difference between the Employment to population ratio(%) in Macedonia and Employment to population ratio(%) in Somalia?
Keep it short and to the point. -27.7. In the year 1998, what is the difference between the Employment to population ratio(%) in Sierra Leone and Employment to population ratio(%) in Somalia?
Provide a succinct answer. -12.6. In the year 1999, what is the difference between the Employment to population ratio(%) of Heavily indebted poor countries and Employment to population ratio(%) of Macedonia?
Give a very brief answer. 31.96. In the year 1999, what is the difference between the Employment to population ratio(%) in Heavily indebted poor countries and Employment to population ratio(%) in Sierra Leone?
Offer a very short reply. 17.66. In the year 1999, what is the difference between the Employment to population ratio(%) of Heavily indebted poor countries and Employment to population ratio(%) of Somalia?
Your answer should be very brief. 4.56. In the year 1999, what is the difference between the Employment to population ratio(%) in Macedonia and Employment to population ratio(%) in Sierra Leone?
Make the answer very short. -14.3. In the year 1999, what is the difference between the Employment to population ratio(%) of Macedonia and Employment to population ratio(%) of Somalia?
Provide a short and direct response. -27.4. In the year 2000, what is the difference between the Employment to population ratio(%) of Heavily indebted poor countries and Employment to population ratio(%) of Macedonia?
Make the answer very short. 31.14. In the year 2000, what is the difference between the Employment to population ratio(%) in Heavily indebted poor countries and Employment to population ratio(%) in Sierra Leone?
Give a very brief answer. 17.44. In the year 2000, what is the difference between the Employment to population ratio(%) of Heavily indebted poor countries and Employment to population ratio(%) of Somalia?
Offer a terse response. 4.54. In the year 2000, what is the difference between the Employment to population ratio(%) in Macedonia and Employment to population ratio(%) in Sierra Leone?
Offer a terse response. -13.7. In the year 2000, what is the difference between the Employment to population ratio(%) in Macedonia and Employment to population ratio(%) in Somalia?
Your answer should be compact. -26.6. In the year 2000, what is the difference between the Employment to population ratio(%) in Sierra Leone and Employment to population ratio(%) in Somalia?
Give a very brief answer. -12.9. What is the ratio of the Employment to population ratio(%) of Heavily indebted poor countries in 1993 to that in 1994?
Keep it short and to the point. 1. What is the ratio of the Employment to population ratio(%) of Macedonia in 1993 to that in 1994?
Offer a very short reply. 1.03. What is the ratio of the Employment to population ratio(%) in Sierra Leone in 1993 to that in 1994?
Your answer should be very brief. 1. What is the ratio of the Employment to population ratio(%) of Macedonia in 1993 to that in 1995?
Your answer should be compact. 1.03. What is the ratio of the Employment to population ratio(%) in Sierra Leone in 1993 to that in 1995?
Make the answer very short. 1.01. What is the ratio of the Employment to population ratio(%) of Macedonia in 1993 to that in 1996?
Your response must be concise. 1.06. What is the ratio of the Employment to population ratio(%) in Sierra Leone in 1993 to that in 1996?
Your answer should be compact. 1.01. What is the ratio of the Employment to population ratio(%) in Macedonia in 1993 to that in 1997?
Keep it short and to the point. 1.11. What is the ratio of the Employment to population ratio(%) in Macedonia in 1993 to that in 1998?
Offer a very short reply. 1.06. What is the ratio of the Employment to population ratio(%) of Sierra Leone in 1993 to that in 1998?
Provide a succinct answer. 1.03. What is the ratio of the Employment to population ratio(%) of Somalia in 1993 to that in 1998?
Provide a succinct answer. 1.01. What is the ratio of the Employment to population ratio(%) in Heavily indebted poor countries in 1993 to that in 1999?
Make the answer very short. 1. What is the ratio of the Employment to population ratio(%) of Macedonia in 1993 to that in 1999?
Offer a terse response. 1.06. What is the ratio of the Employment to population ratio(%) of Sierra Leone in 1993 to that in 1999?
Ensure brevity in your answer.  1.04. What is the ratio of the Employment to population ratio(%) in Somalia in 1993 to that in 1999?
Offer a very short reply. 1.01. What is the ratio of the Employment to population ratio(%) in Macedonia in 1993 to that in 2000?
Give a very brief answer. 1.04. What is the ratio of the Employment to population ratio(%) in Sierra Leone in 1993 to that in 2000?
Keep it short and to the point. 1.04. What is the ratio of the Employment to population ratio(%) of Somalia in 1993 to that in 2000?
Your answer should be very brief. 1.01. What is the ratio of the Employment to population ratio(%) of Macedonia in 1994 to that in 1995?
Give a very brief answer. 1. What is the ratio of the Employment to population ratio(%) in Sierra Leone in 1994 to that in 1995?
Your response must be concise. 1.01. What is the ratio of the Employment to population ratio(%) of Somalia in 1994 to that in 1995?
Offer a terse response. 1. What is the ratio of the Employment to population ratio(%) of Heavily indebted poor countries in 1994 to that in 1996?
Your response must be concise. 1. What is the ratio of the Employment to population ratio(%) of Macedonia in 1994 to that in 1996?
Your answer should be compact. 1.03. What is the ratio of the Employment to population ratio(%) of Sierra Leone in 1994 to that in 1996?
Provide a succinct answer. 1.01. What is the ratio of the Employment to population ratio(%) of Somalia in 1994 to that in 1996?
Offer a very short reply. 1. What is the ratio of the Employment to population ratio(%) of Heavily indebted poor countries in 1994 to that in 1997?
Give a very brief answer. 1. What is the ratio of the Employment to population ratio(%) of Macedonia in 1994 to that in 1997?
Give a very brief answer. 1.08. What is the ratio of the Employment to population ratio(%) of Sierra Leone in 1994 to that in 1997?
Ensure brevity in your answer.  1.02. What is the ratio of the Employment to population ratio(%) in Macedonia in 1994 to that in 1998?
Ensure brevity in your answer.  1.03. What is the ratio of the Employment to population ratio(%) of Sierra Leone in 1994 to that in 1998?
Keep it short and to the point. 1.03. What is the ratio of the Employment to population ratio(%) in Heavily indebted poor countries in 1994 to that in 1999?
Offer a terse response. 1. What is the ratio of the Employment to population ratio(%) of Macedonia in 1994 to that in 1999?
Ensure brevity in your answer.  1.03. What is the ratio of the Employment to population ratio(%) of Sierra Leone in 1994 to that in 1999?
Ensure brevity in your answer.  1.04. What is the ratio of the Employment to population ratio(%) in Macedonia in 1994 to that in 2000?
Keep it short and to the point. 1.01. What is the ratio of the Employment to population ratio(%) in Sierra Leone in 1994 to that in 2000?
Keep it short and to the point. 1.04. What is the ratio of the Employment to population ratio(%) of Somalia in 1994 to that in 2000?
Ensure brevity in your answer.  1.01. What is the ratio of the Employment to population ratio(%) of Heavily indebted poor countries in 1995 to that in 1996?
Offer a terse response. 1. What is the ratio of the Employment to population ratio(%) of Macedonia in 1995 to that in 1996?
Your answer should be compact. 1.03. What is the ratio of the Employment to population ratio(%) in Sierra Leone in 1995 to that in 1996?
Ensure brevity in your answer.  1. What is the ratio of the Employment to population ratio(%) in Somalia in 1995 to that in 1996?
Make the answer very short. 1. What is the ratio of the Employment to population ratio(%) of Heavily indebted poor countries in 1995 to that in 1997?
Your answer should be compact. 1. What is the ratio of the Employment to population ratio(%) in Macedonia in 1995 to that in 1997?
Ensure brevity in your answer.  1.08. What is the ratio of the Employment to population ratio(%) in Sierra Leone in 1995 to that in 1997?
Provide a succinct answer. 1.02. What is the ratio of the Employment to population ratio(%) in Macedonia in 1995 to that in 1998?
Provide a short and direct response. 1.03. What is the ratio of the Employment to population ratio(%) of Sierra Leone in 1995 to that in 1998?
Ensure brevity in your answer.  1.02. What is the ratio of the Employment to population ratio(%) in Somalia in 1995 to that in 1998?
Provide a succinct answer. 1. What is the ratio of the Employment to population ratio(%) of Heavily indebted poor countries in 1995 to that in 1999?
Make the answer very short. 1. What is the ratio of the Employment to population ratio(%) of Macedonia in 1995 to that in 1999?
Provide a succinct answer. 1.03. What is the ratio of the Employment to population ratio(%) of Sierra Leone in 1995 to that in 1999?
Ensure brevity in your answer.  1.03. What is the ratio of the Employment to population ratio(%) in Macedonia in 1995 to that in 2000?
Ensure brevity in your answer.  1.01. What is the ratio of the Employment to population ratio(%) in Sierra Leone in 1995 to that in 2000?
Provide a succinct answer. 1.03. What is the ratio of the Employment to population ratio(%) in Somalia in 1995 to that in 2000?
Your response must be concise. 1.01. What is the ratio of the Employment to population ratio(%) of Macedonia in 1996 to that in 1997?
Give a very brief answer. 1.05. What is the ratio of the Employment to population ratio(%) in Sierra Leone in 1996 to that in 1997?
Give a very brief answer. 1.02. What is the ratio of the Employment to population ratio(%) of Sierra Leone in 1996 to that in 1998?
Your answer should be compact. 1.02. What is the ratio of the Employment to population ratio(%) in Macedonia in 1996 to that in 1999?
Keep it short and to the point. 1. What is the ratio of the Employment to population ratio(%) of Sierra Leone in 1996 to that in 1999?
Ensure brevity in your answer.  1.03. What is the ratio of the Employment to population ratio(%) in Sierra Leone in 1996 to that in 2000?
Provide a succinct answer. 1.03. What is the ratio of the Employment to population ratio(%) in Macedonia in 1997 to that in 1998?
Provide a succinct answer. 0.96. What is the ratio of the Employment to population ratio(%) in Somalia in 1997 to that in 1998?
Keep it short and to the point. 1. What is the ratio of the Employment to population ratio(%) of Macedonia in 1997 to that in 1999?
Your response must be concise. 0.95. What is the ratio of the Employment to population ratio(%) of Sierra Leone in 1997 to that in 1999?
Provide a short and direct response. 1.01. What is the ratio of the Employment to population ratio(%) in Somalia in 1997 to that in 1999?
Give a very brief answer. 1. What is the ratio of the Employment to population ratio(%) in Heavily indebted poor countries in 1997 to that in 2000?
Offer a terse response. 1. What is the ratio of the Employment to population ratio(%) in Macedonia in 1997 to that in 2000?
Keep it short and to the point. 0.94. What is the ratio of the Employment to population ratio(%) of Sierra Leone in 1997 to that in 2000?
Give a very brief answer. 1.01. What is the ratio of the Employment to population ratio(%) of Heavily indebted poor countries in 1998 to that in 1999?
Your answer should be very brief. 1. What is the ratio of the Employment to population ratio(%) of Sierra Leone in 1998 to that in 1999?
Offer a terse response. 1.01. What is the ratio of the Employment to population ratio(%) of Somalia in 1998 to that in 1999?
Ensure brevity in your answer.  1. What is the ratio of the Employment to population ratio(%) of Macedonia in 1998 to that in 2000?
Offer a terse response. 0.98. What is the ratio of the Employment to population ratio(%) in Sierra Leone in 1998 to that in 2000?
Provide a succinct answer. 1.01. What is the ratio of the Employment to population ratio(%) of Somalia in 1998 to that in 2000?
Provide a succinct answer. 1. What is the ratio of the Employment to population ratio(%) of Macedonia in 1999 to that in 2000?
Provide a short and direct response. 0.98. What is the difference between the highest and the second highest Employment to population ratio(%) of Heavily indebted poor countries?
Your response must be concise. 0.03. What is the difference between the highest and the second highest Employment to population ratio(%) in Macedonia?
Offer a terse response. 1.4. What is the difference between the highest and the second highest Employment to population ratio(%) of Sierra Leone?
Provide a succinct answer. 0.3. What is the difference between the highest and the lowest Employment to population ratio(%) in Heavily indebted poor countries?
Ensure brevity in your answer.  0.47. What is the difference between the highest and the lowest Employment to population ratio(%) in Sierra Leone?
Offer a very short reply. 2.6. 